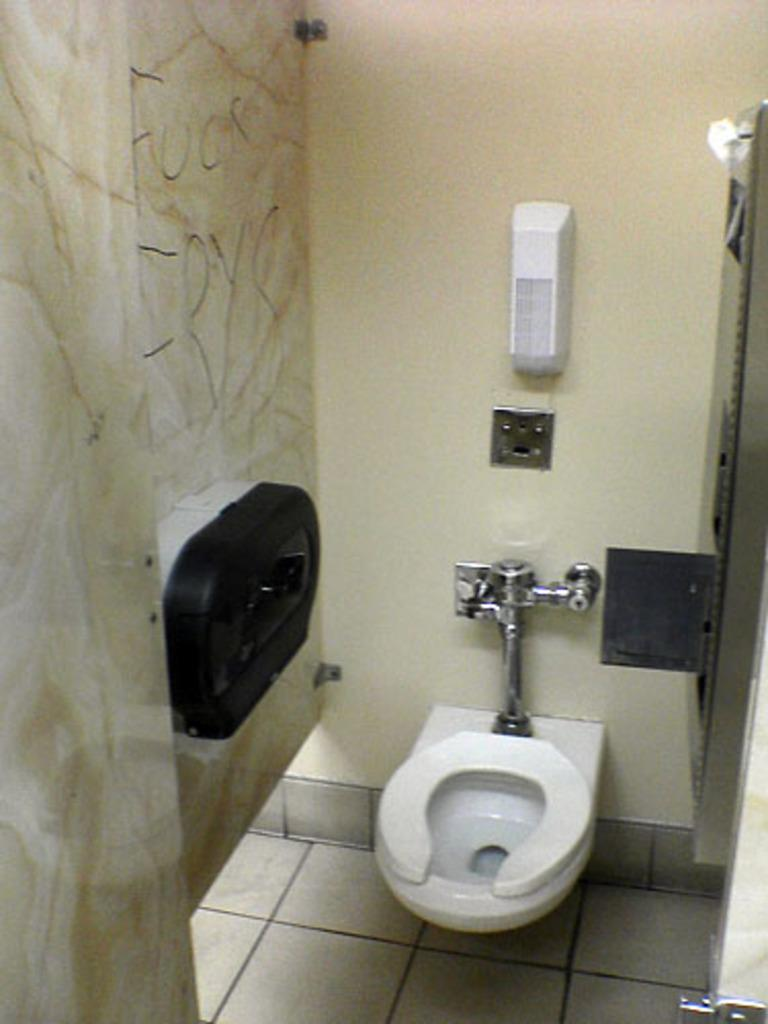What color is the toilet in the image? The toilet in the image is white. What can be found attached to the wall in the image? There is a soap dispenser attached to the wall in the image. What is used for dispensing water in the image? There are taps visible in the image. What color is the wall in the image? The wall in the image is in cream color. What type of ink is used to write on the wall in the image? There is no writing or ink present on the wall in the image. How many teeth can be seen in the image? There are no teeth visible in the image. 